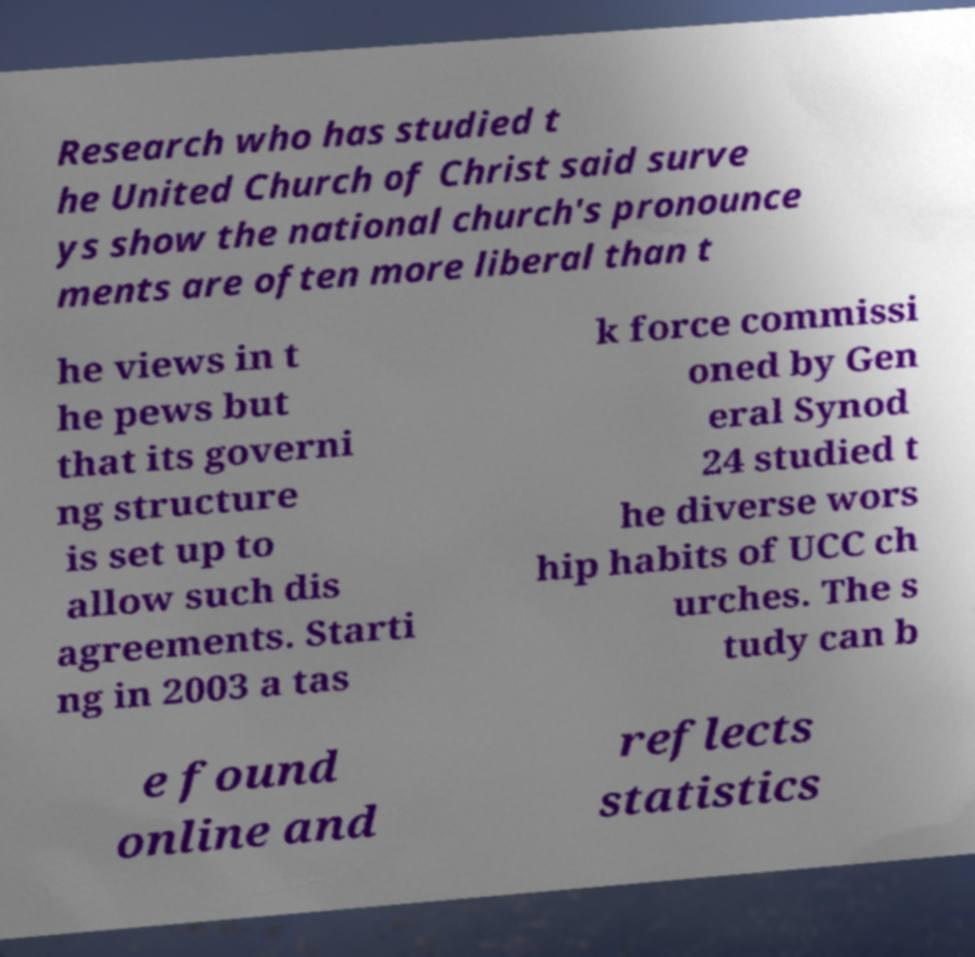Can you accurately transcribe the text from the provided image for me? Research who has studied t he United Church of Christ said surve ys show the national church's pronounce ments are often more liberal than t he views in t he pews but that its governi ng structure is set up to allow such dis agreements. Starti ng in 2003 a tas k force commissi oned by Gen eral Synod 24 studied t he diverse wors hip habits of UCC ch urches. The s tudy can b e found online and reflects statistics 